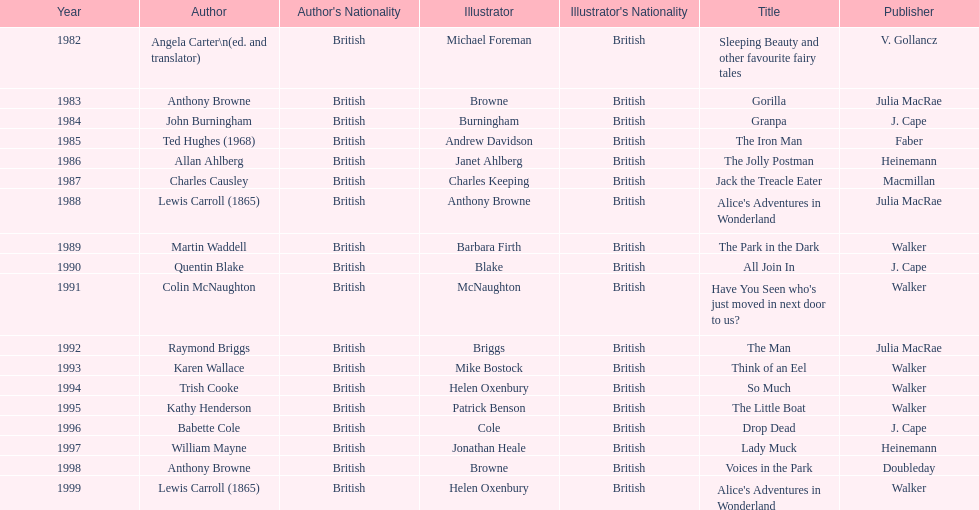How many total titles were published by walker? 5. 